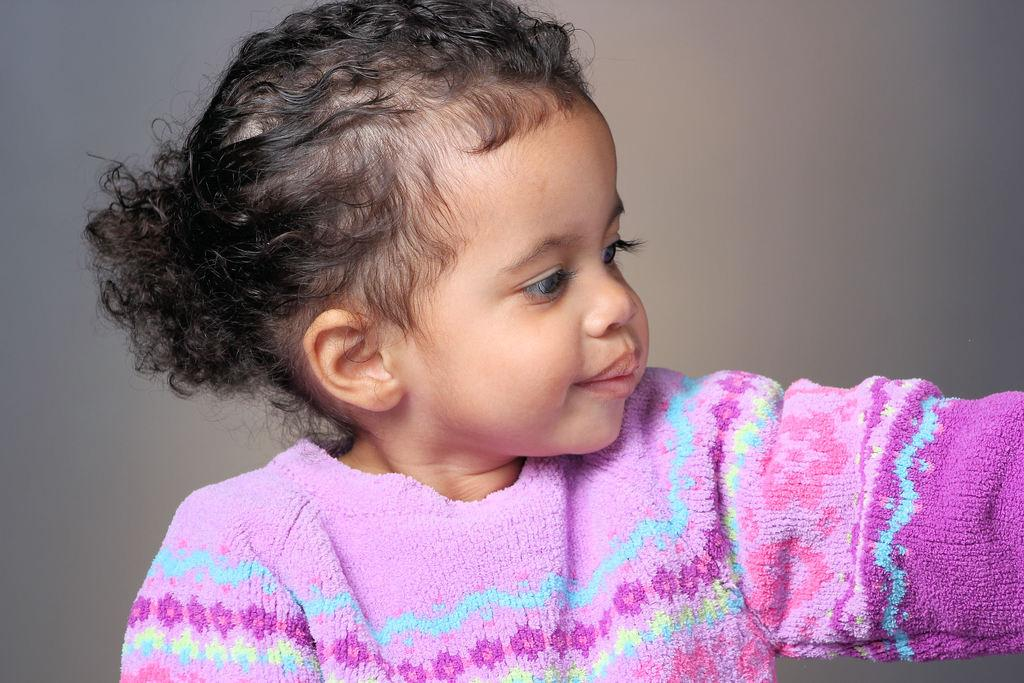What is the main subject of the image? The main subject of the image is a baby girl. What is the baby girl wearing in the image? The baby girl is wearing a pink dress. Can you see any sea creatures in the image? There are no sea creatures present in the image. What type of face is visible on the baby girl's head in the image? The image only shows the baby girl wearing a pink dress, and there is no specific detail about her face or head mentioned in the facts provided. 